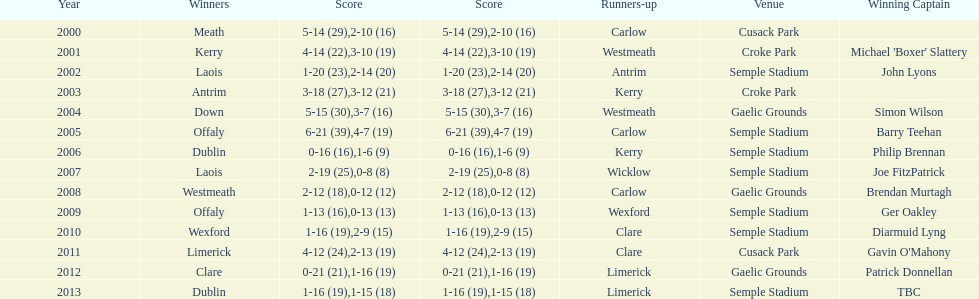Who was the initial victorious leader? Michael 'Boxer' Slattery. 